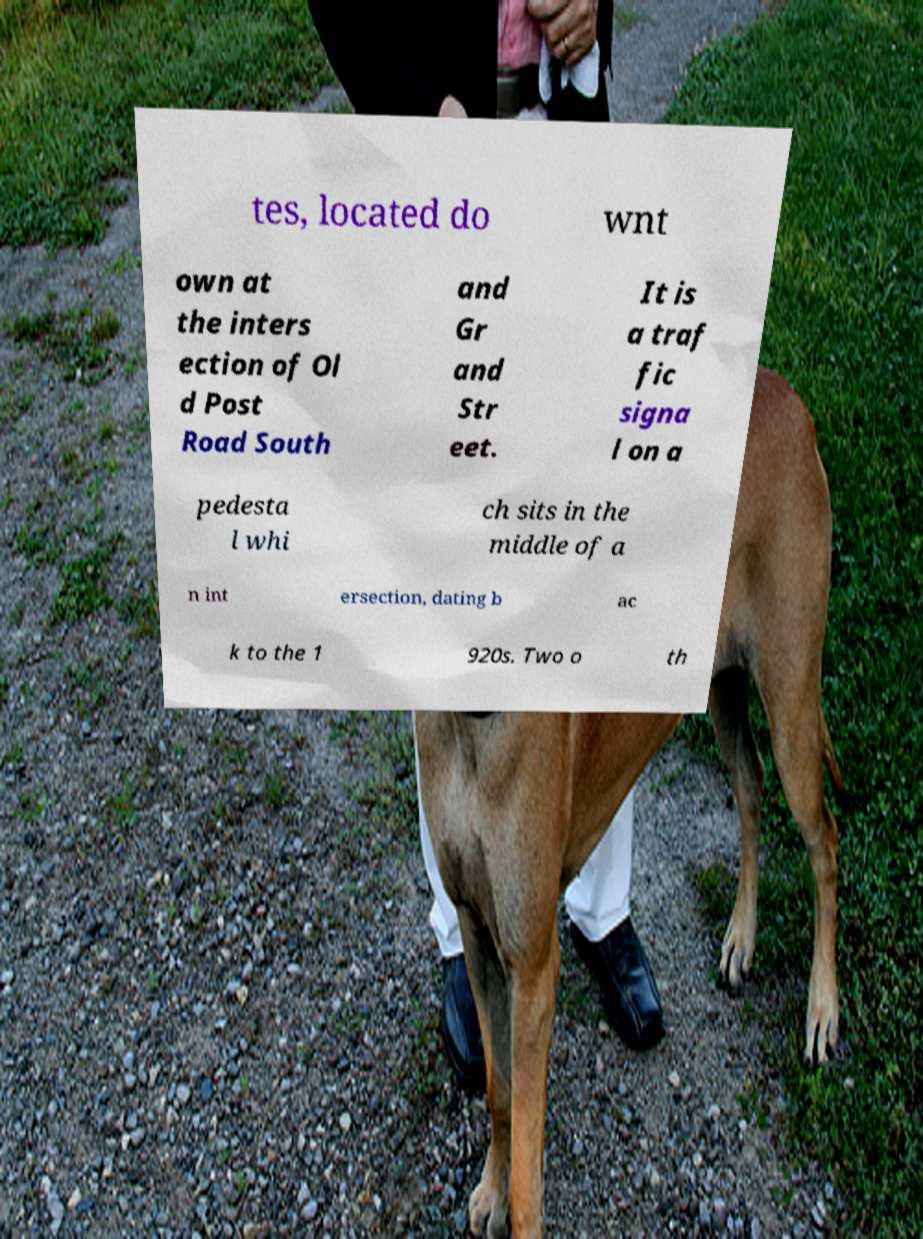There's text embedded in this image that I need extracted. Can you transcribe it verbatim? tes, located do wnt own at the inters ection of Ol d Post Road South and Gr and Str eet. It is a traf fic signa l on a pedesta l whi ch sits in the middle of a n int ersection, dating b ac k to the 1 920s. Two o th 